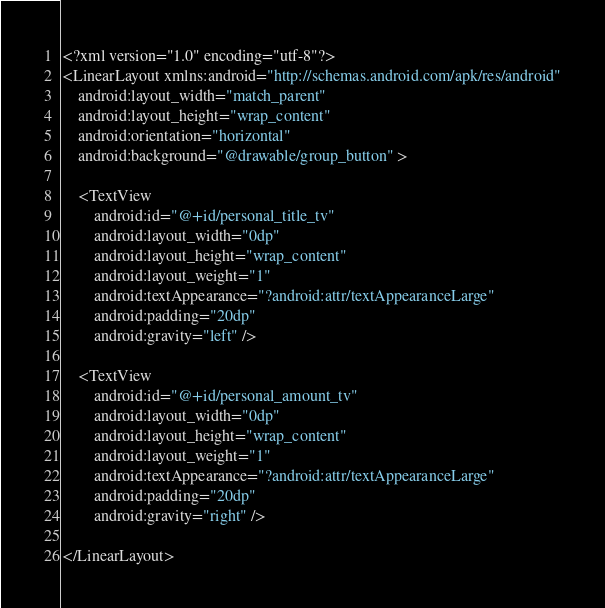<code> <loc_0><loc_0><loc_500><loc_500><_XML_><?xml version="1.0" encoding="utf-8"?>
<LinearLayout xmlns:android="http://schemas.android.com/apk/res/android"
    android:layout_width="match_parent"
    android:layout_height="wrap_content"
    android:orientation="horizontal"
    android:background="@drawable/group_button" >

    <TextView
        android:id="@+id/personal_title_tv"
        android:layout_width="0dp"
        android:layout_height="wrap_content"
        android:layout_weight="1"
        android:textAppearance="?android:attr/textAppearanceLarge"
        android:padding="20dp"
        android:gravity="left" />

    <TextView
        android:id="@+id/personal_amount_tv"
        android:layout_width="0dp"
        android:layout_height="wrap_content"
        android:layout_weight="1"
        android:textAppearance="?android:attr/textAppearanceLarge"
        android:padding="20dp"
        android:gravity="right" />
    
</LinearLayout>
</code> 